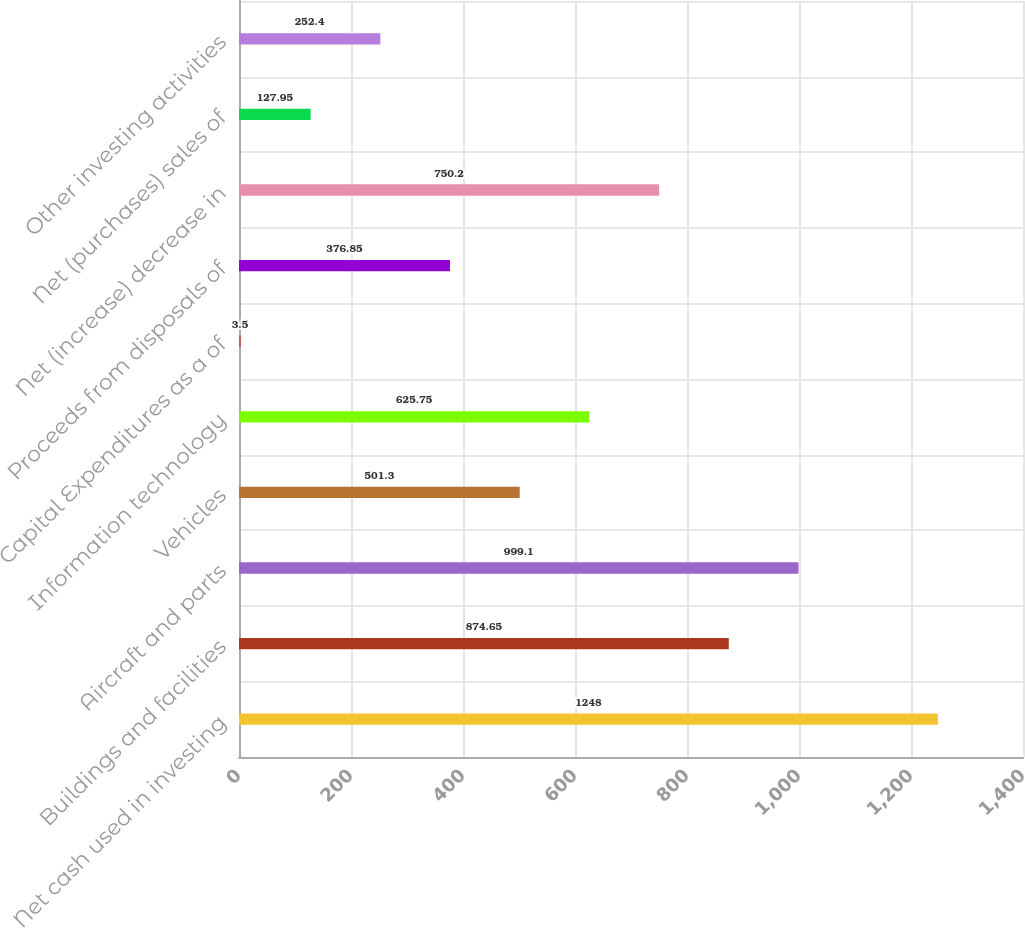Convert chart to OTSL. <chart><loc_0><loc_0><loc_500><loc_500><bar_chart><fcel>Net cash used in investing<fcel>Buildings and facilities<fcel>Aircraft and parts<fcel>Vehicles<fcel>Information technology<fcel>Capital Expenditures as a of<fcel>Proceeds from disposals of<fcel>Net (increase) decrease in<fcel>Net (purchases) sales of<fcel>Other investing activities<nl><fcel>1248<fcel>874.65<fcel>999.1<fcel>501.3<fcel>625.75<fcel>3.5<fcel>376.85<fcel>750.2<fcel>127.95<fcel>252.4<nl></chart> 